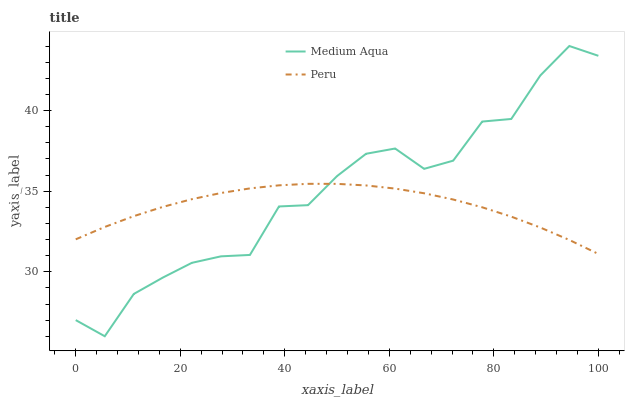Does Peru have the minimum area under the curve?
Answer yes or no. Yes. Does Medium Aqua have the maximum area under the curve?
Answer yes or no. Yes. Does Peru have the maximum area under the curve?
Answer yes or no. No. Is Peru the smoothest?
Answer yes or no. Yes. Is Medium Aqua the roughest?
Answer yes or no. Yes. Is Peru the roughest?
Answer yes or no. No. Does Medium Aqua have the lowest value?
Answer yes or no. Yes. Does Peru have the lowest value?
Answer yes or no. No. Does Medium Aqua have the highest value?
Answer yes or no. Yes. Does Peru have the highest value?
Answer yes or no. No. Does Peru intersect Medium Aqua?
Answer yes or no. Yes. Is Peru less than Medium Aqua?
Answer yes or no. No. Is Peru greater than Medium Aqua?
Answer yes or no. No. 